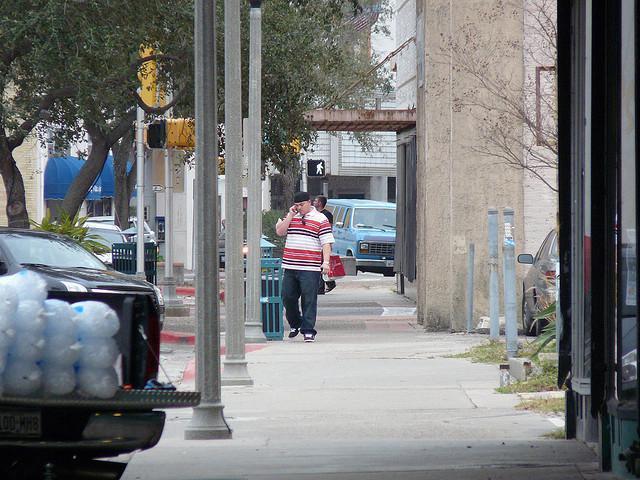How many cars are there?
Give a very brief answer. 2. How many trucks are there?
Give a very brief answer. 2. How many pizza paddles are on top of the oven?
Give a very brief answer. 0. 